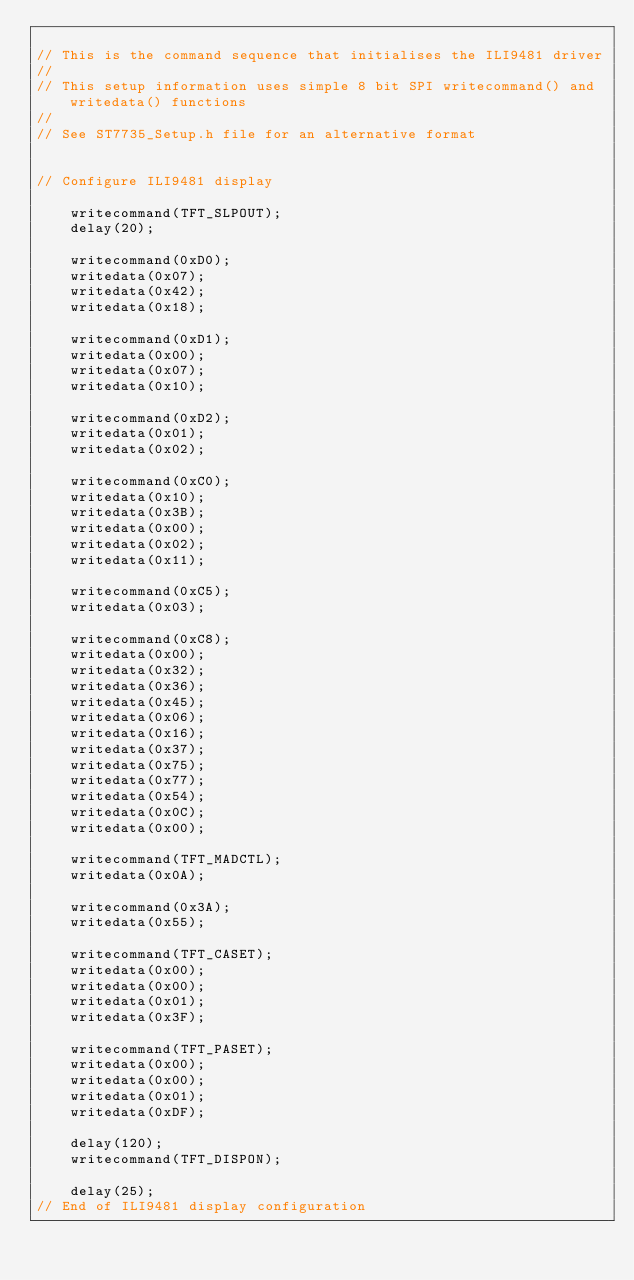Convert code to text. <code><loc_0><loc_0><loc_500><loc_500><_C_>
// This is the command sequence that initialises the ILI9481 driver
//
// This setup information uses simple 8 bit SPI writecommand() and writedata() functions
//
// See ST7735_Setup.h file for an alternative format


// Configure ILI9481 display

    writecommand(TFT_SLPOUT);
    delay(20);

    writecommand(0xD0);
    writedata(0x07);
    writedata(0x42);
    writedata(0x18);

    writecommand(0xD1);
    writedata(0x00);
    writedata(0x07);
    writedata(0x10);

    writecommand(0xD2);
    writedata(0x01);
    writedata(0x02);

    writecommand(0xC0);
    writedata(0x10);
    writedata(0x3B);
    writedata(0x00);
    writedata(0x02);
    writedata(0x11);

    writecommand(0xC5);
    writedata(0x03);

    writecommand(0xC8);
    writedata(0x00);
    writedata(0x32);
    writedata(0x36);
    writedata(0x45);
    writedata(0x06);
    writedata(0x16);
    writedata(0x37);
    writedata(0x75);
    writedata(0x77);
    writedata(0x54);
    writedata(0x0C);
    writedata(0x00);

    writecommand(TFT_MADCTL);
    writedata(0x0A);

    writecommand(0x3A);
    writedata(0x55);

    writecommand(TFT_CASET);
    writedata(0x00);
    writedata(0x00);
    writedata(0x01);
    writedata(0x3F);

    writecommand(TFT_PASET);
    writedata(0x00);
    writedata(0x00);
    writedata(0x01);
    writedata(0xDF);

    delay(120);
    writecommand(TFT_DISPON);

    delay(25);
// End of ILI9481 display configuration



</code> 